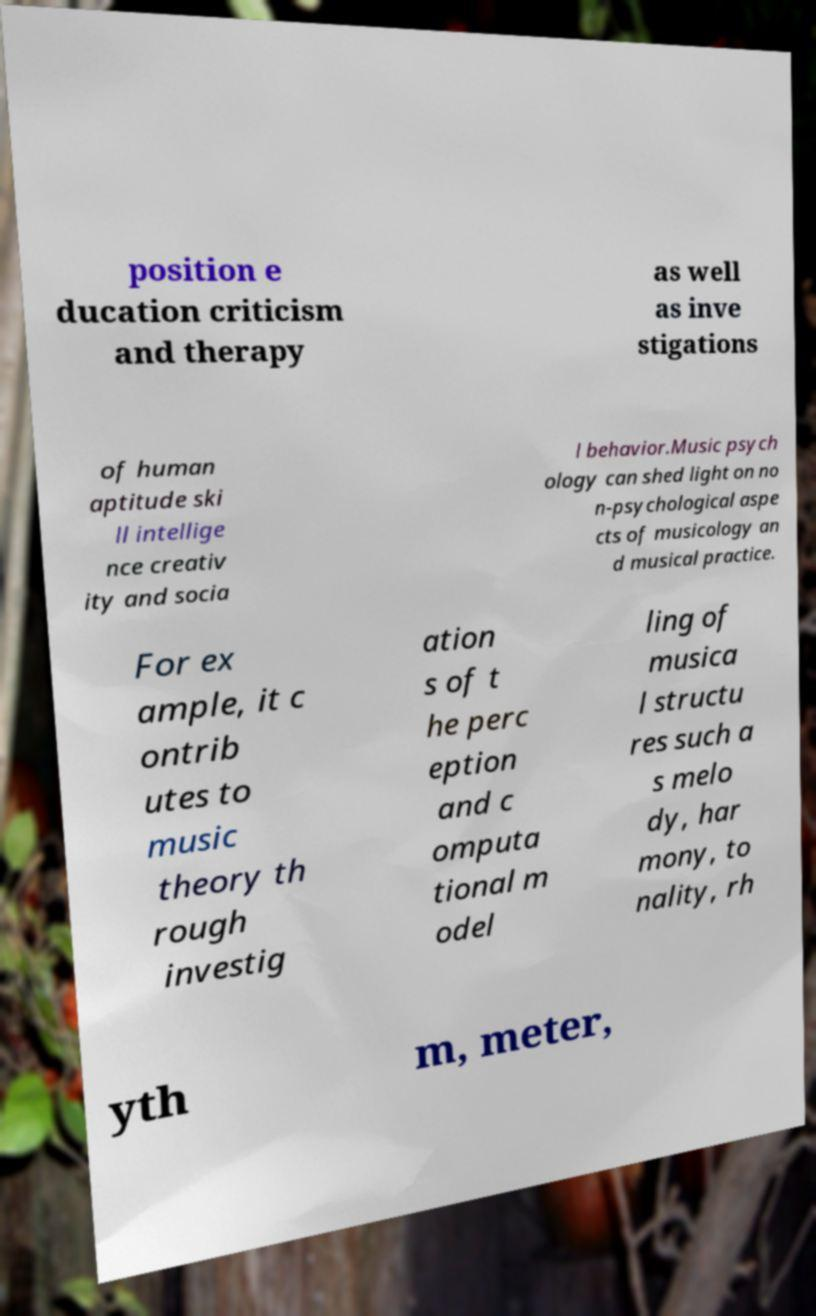I need the written content from this picture converted into text. Can you do that? position e ducation criticism and therapy as well as inve stigations of human aptitude ski ll intellige nce creativ ity and socia l behavior.Music psych ology can shed light on no n-psychological aspe cts of musicology an d musical practice. For ex ample, it c ontrib utes to music theory th rough investig ation s of t he perc eption and c omputa tional m odel ling of musica l structu res such a s melo dy, har mony, to nality, rh yth m, meter, 